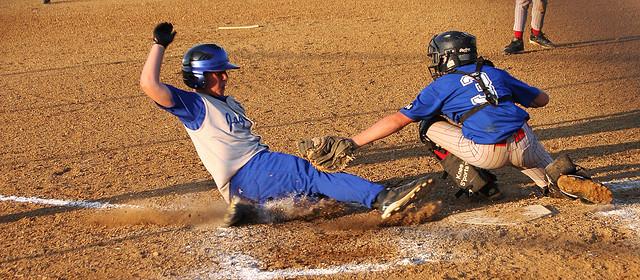What color is the man's helmet?
Give a very brief answer. Blue. The umpire wearing a number 6?
Give a very brief answer. No. Is he safe?
Write a very short answer. No. What type of sneakers are the players playing in?
Quick response, please. Cleats. 